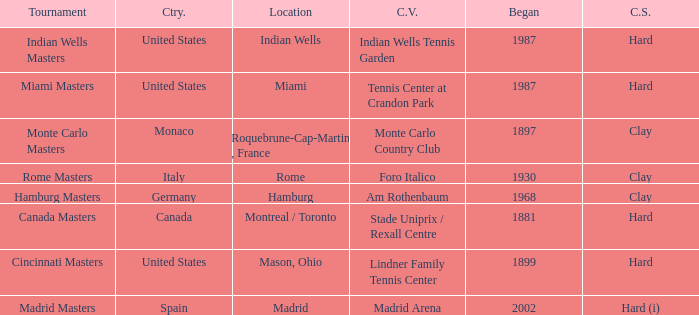Which tournaments current venue is the Madrid Arena? Madrid Masters. 